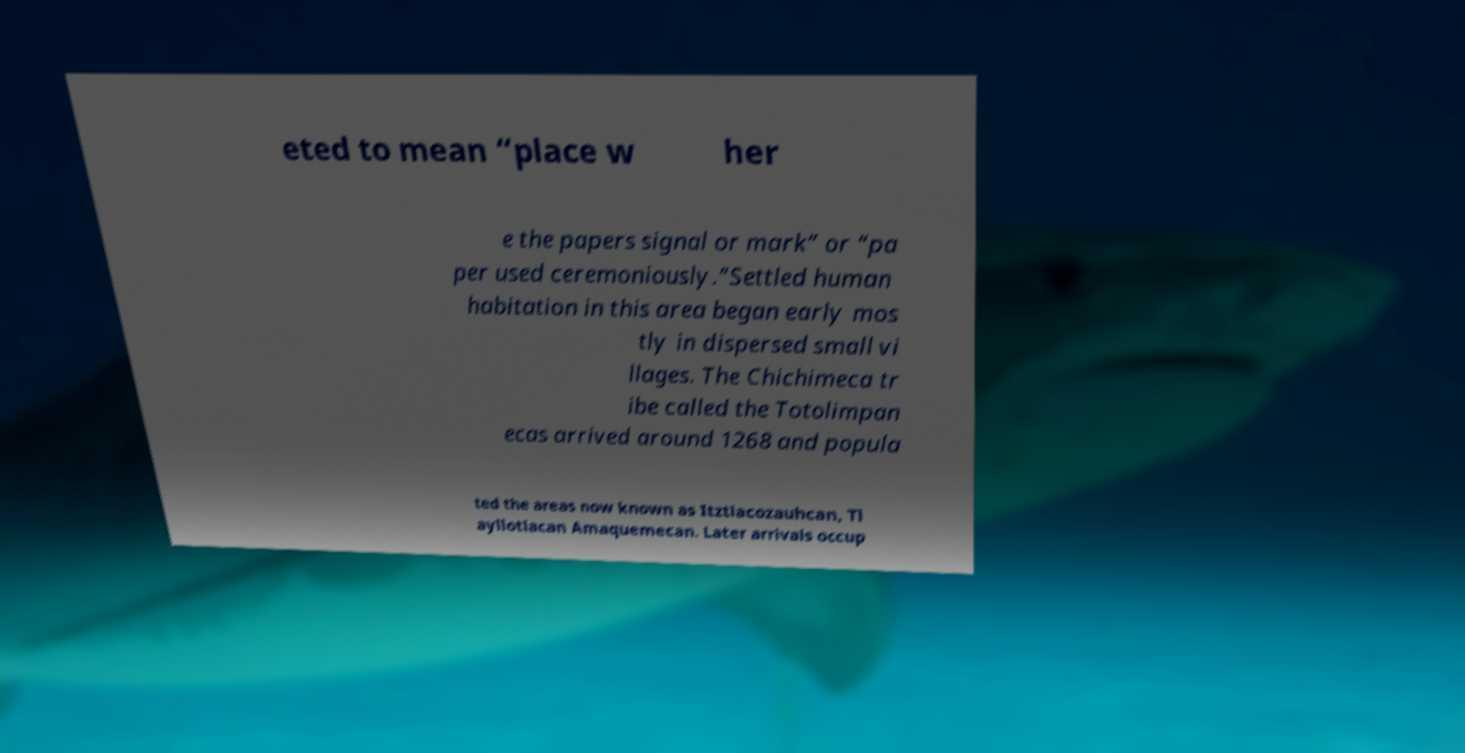Please identify and transcribe the text found in this image. eted to mean “place w her e the papers signal or mark” or “pa per used ceremoniously.”Settled human habitation in this area began early mos tly in dispersed small vi llages. The Chichimeca tr ibe called the Totolimpan ecas arrived around 1268 and popula ted the areas now known as Itztlacozauhcan, Tl ayllotlacan Amaquemecan. Later arrivals occup 